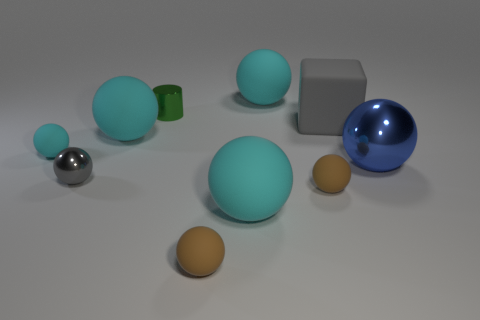What material is the small gray sphere?
Keep it short and to the point. Metal. How many cyan spheres are the same material as the blue ball?
Ensure brevity in your answer.  0. What number of matte things are either big gray things or cyan spheres?
Ensure brevity in your answer.  5. Do the cyan matte object in front of the big blue thing and the small shiny thing in front of the large metal ball have the same shape?
Your response must be concise. Yes. What color is the large object that is left of the matte block and in front of the small cyan thing?
Offer a terse response. Cyan. Is the size of the gray thing that is to the left of the cylinder the same as the shiny object behind the cube?
Provide a short and direct response. Yes. How many small objects have the same color as the cube?
Make the answer very short. 1. How many large things are either metal spheres or brown metal cylinders?
Your answer should be very brief. 1. Does the small sphere on the left side of the small gray metal ball have the same material as the blue object?
Offer a very short reply. No. The metallic ball that is to the right of the gray metallic thing is what color?
Give a very brief answer. Blue. 